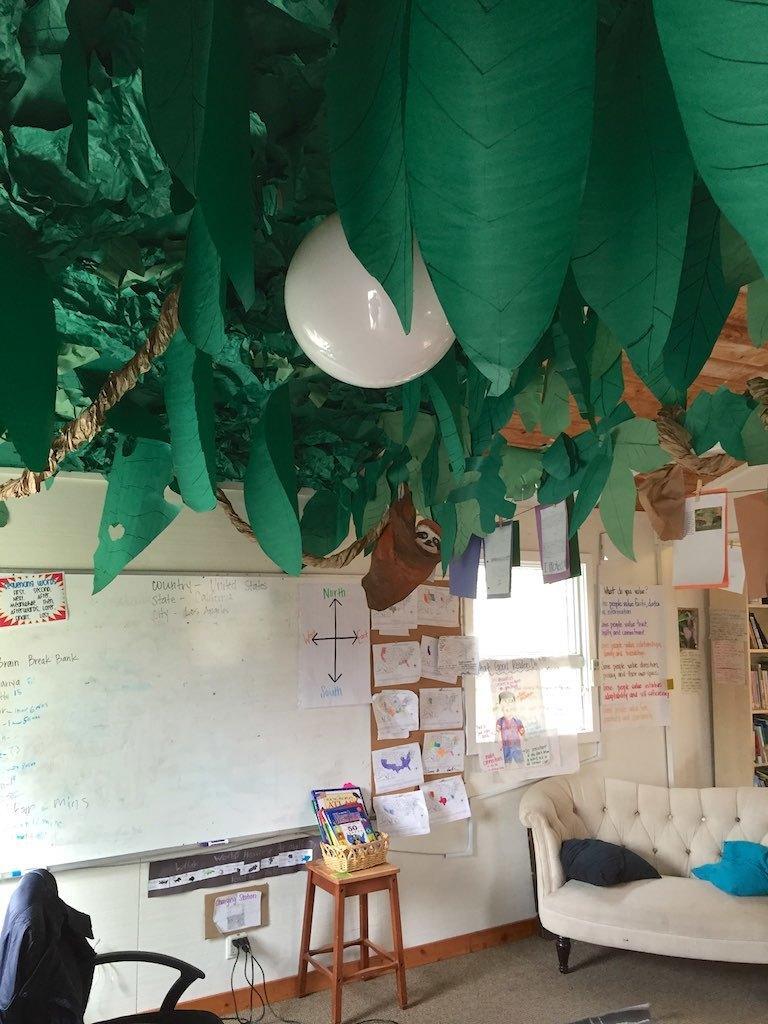Describe this image in one or two sentences. The picture is like a classroom. On the left there is a board, chair, stool, books and charger. On the right there is couch, chart, bookshelf. In the center of the image there is window, a notice board and papers attached on it. On the top there are leaves and a bulb. 